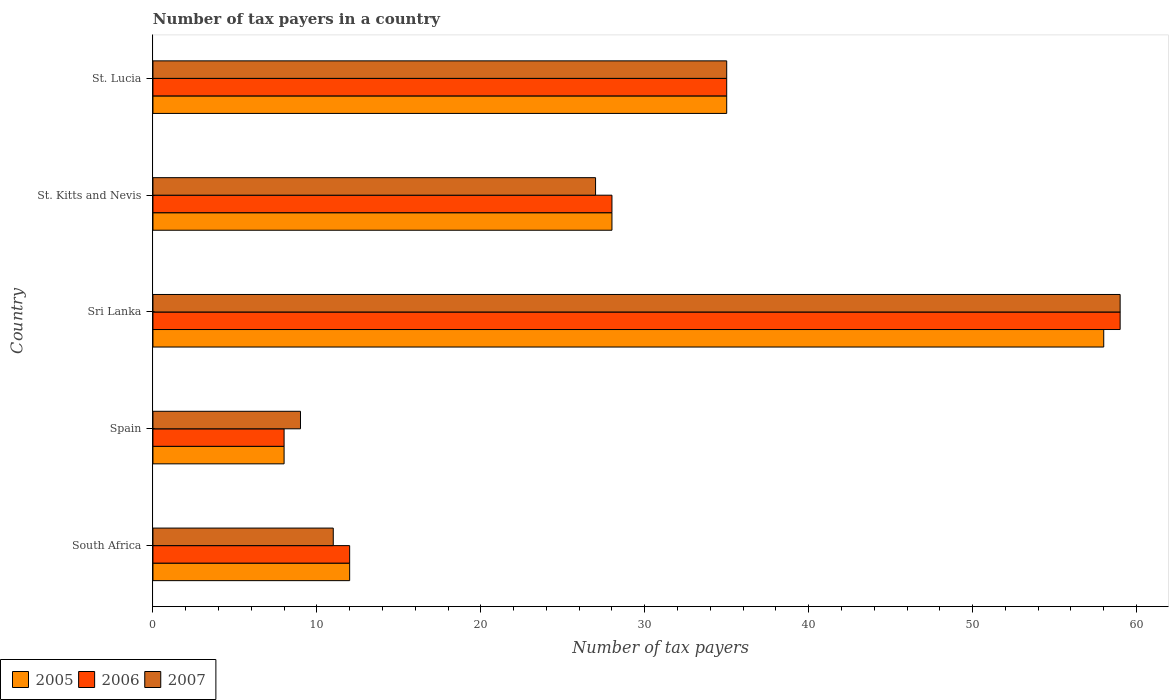How many different coloured bars are there?
Offer a terse response. 3. How many groups of bars are there?
Your answer should be very brief. 5. Are the number of bars on each tick of the Y-axis equal?
Your answer should be compact. Yes. How many bars are there on the 3rd tick from the bottom?
Provide a succinct answer. 3. What is the label of the 3rd group of bars from the top?
Offer a terse response. Sri Lanka. What is the number of tax payers in in 2007 in Sri Lanka?
Keep it short and to the point. 59. Across all countries, what is the maximum number of tax payers in in 2005?
Offer a terse response. 58. In which country was the number of tax payers in in 2005 maximum?
Make the answer very short. Sri Lanka. In which country was the number of tax payers in in 2005 minimum?
Ensure brevity in your answer.  Spain. What is the total number of tax payers in in 2006 in the graph?
Offer a terse response. 142. What is the difference between the number of tax payers in in 2007 in South Africa and that in Sri Lanka?
Provide a short and direct response. -48. What is the difference between the number of tax payers in in 2007 in Spain and the number of tax payers in in 2006 in South Africa?
Offer a very short reply. -3. What is the average number of tax payers in in 2005 per country?
Ensure brevity in your answer.  28.2. What is the ratio of the number of tax payers in in 2007 in Sri Lanka to that in St. Kitts and Nevis?
Offer a very short reply. 2.19. What is the difference between the highest and the lowest number of tax payers in in 2007?
Make the answer very short. 50. Is it the case that in every country, the sum of the number of tax payers in in 2007 and number of tax payers in in 2005 is greater than the number of tax payers in in 2006?
Keep it short and to the point. Yes. What is the difference between two consecutive major ticks on the X-axis?
Make the answer very short. 10. Are the values on the major ticks of X-axis written in scientific E-notation?
Your answer should be very brief. No. Does the graph contain any zero values?
Give a very brief answer. No. Where does the legend appear in the graph?
Your answer should be very brief. Bottom left. How are the legend labels stacked?
Offer a terse response. Horizontal. What is the title of the graph?
Your answer should be very brief. Number of tax payers in a country. What is the label or title of the X-axis?
Your answer should be compact. Number of tax payers. What is the Number of tax payers in 2005 in South Africa?
Keep it short and to the point. 12. What is the Number of tax payers of 2006 in South Africa?
Make the answer very short. 12. What is the Number of tax payers in 2007 in South Africa?
Offer a very short reply. 11. What is the Number of tax payers of 2005 in Sri Lanka?
Your answer should be very brief. 58. What is the Number of tax payers in 2006 in Sri Lanka?
Provide a short and direct response. 59. What is the Number of tax payers of 2005 in St. Kitts and Nevis?
Your answer should be very brief. 28. What is the Number of tax payers of 2005 in St. Lucia?
Give a very brief answer. 35. What is the Number of tax payers in 2006 in St. Lucia?
Provide a short and direct response. 35. Across all countries, what is the maximum Number of tax payers in 2006?
Give a very brief answer. 59. Across all countries, what is the maximum Number of tax payers of 2007?
Keep it short and to the point. 59. Across all countries, what is the minimum Number of tax payers in 2006?
Ensure brevity in your answer.  8. Across all countries, what is the minimum Number of tax payers of 2007?
Make the answer very short. 9. What is the total Number of tax payers of 2005 in the graph?
Your answer should be very brief. 141. What is the total Number of tax payers in 2006 in the graph?
Offer a very short reply. 142. What is the total Number of tax payers of 2007 in the graph?
Ensure brevity in your answer.  141. What is the difference between the Number of tax payers of 2006 in South Africa and that in Spain?
Keep it short and to the point. 4. What is the difference between the Number of tax payers of 2007 in South Africa and that in Spain?
Ensure brevity in your answer.  2. What is the difference between the Number of tax payers in 2005 in South Africa and that in Sri Lanka?
Make the answer very short. -46. What is the difference between the Number of tax payers of 2006 in South Africa and that in Sri Lanka?
Offer a terse response. -47. What is the difference between the Number of tax payers of 2007 in South Africa and that in Sri Lanka?
Provide a succinct answer. -48. What is the difference between the Number of tax payers of 2005 in South Africa and that in St. Kitts and Nevis?
Give a very brief answer. -16. What is the difference between the Number of tax payers of 2007 in South Africa and that in St. Lucia?
Give a very brief answer. -24. What is the difference between the Number of tax payers of 2006 in Spain and that in Sri Lanka?
Provide a succinct answer. -51. What is the difference between the Number of tax payers of 2007 in Spain and that in Sri Lanka?
Offer a very short reply. -50. What is the difference between the Number of tax payers in 2005 in Spain and that in St. Lucia?
Ensure brevity in your answer.  -27. What is the difference between the Number of tax payers of 2005 in Sri Lanka and that in St. Kitts and Nevis?
Give a very brief answer. 30. What is the difference between the Number of tax payers of 2005 in Sri Lanka and that in St. Lucia?
Give a very brief answer. 23. What is the difference between the Number of tax payers of 2006 in Sri Lanka and that in St. Lucia?
Offer a very short reply. 24. What is the difference between the Number of tax payers of 2006 in St. Kitts and Nevis and that in St. Lucia?
Make the answer very short. -7. What is the difference between the Number of tax payers in 2007 in St. Kitts and Nevis and that in St. Lucia?
Give a very brief answer. -8. What is the difference between the Number of tax payers of 2005 in South Africa and the Number of tax payers of 2006 in Spain?
Ensure brevity in your answer.  4. What is the difference between the Number of tax payers of 2005 in South Africa and the Number of tax payers of 2007 in Spain?
Offer a very short reply. 3. What is the difference between the Number of tax payers of 2005 in South Africa and the Number of tax payers of 2006 in Sri Lanka?
Make the answer very short. -47. What is the difference between the Number of tax payers in 2005 in South Africa and the Number of tax payers in 2007 in Sri Lanka?
Offer a terse response. -47. What is the difference between the Number of tax payers of 2006 in South Africa and the Number of tax payers of 2007 in Sri Lanka?
Provide a short and direct response. -47. What is the difference between the Number of tax payers of 2006 in South Africa and the Number of tax payers of 2007 in St. Kitts and Nevis?
Provide a short and direct response. -15. What is the difference between the Number of tax payers in 2005 in South Africa and the Number of tax payers in 2007 in St. Lucia?
Provide a succinct answer. -23. What is the difference between the Number of tax payers in 2005 in Spain and the Number of tax payers in 2006 in Sri Lanka?
Provide a succinct answer. -51. What is the difference between the Number of tax payers in 2005 in Spain and the Number of tax payers in 2007 in Sri Lanka?
Your answer should be compact. -51. What is the difference between the Number of tax payers of 2006 in Spain and the Number of tax payers of 2007 in Sri Lanka?
Offer a terse response. -51. What is the difference between the Number of tax payers in 2005 in Spain and the Number of tax payers in 2006 in St. Kitts and Nevis?
Offer a terse response. -20. What is the difference between the Number of tax payers in 2006 in Spain and the Number of tax payers in 2007 in St. Kitts and Nevis?
Keep it short and to the point. -19. What is the difference between the Number of tax payers in 2005 in Spain and the Number of tax payers in 2006 in St. Lucia?
Provide a succinct answer. -27. What is the difference between the Number of tax payers in 2005 in Spain and the Number of tax payers in 2007 in St. Lucia?
Make the answer very short. -27. What is the difference between the Number of tax payers of 2005 in Sri Lanka and the Number of tax payers of 2007 in St. Kitts and Nevis?
Offer a very short reply. 31. What is the difference between the Number of tax payers in 2005 in St. Kitts and Nevis and the Number of tax payers in 2006 in St. Lucia?
Your response must be concise. -7. What is the difference between the Number of tax payers in 2005 in St. Kitts and Nevis and the Number of tax payers in 2007 in St. Lucia?
Provide a short and direct response. -7. What is the average Number of tax payers of 2005 per country?
Provide a succinct answer. 28.2. What is the average Number of tax payers of 2006 per country?
Your answer should be very brief. 28.4. What is the average Number of tax payers of 2007 per country?
Keep it short and to the point. 28.2. What is the difference between the Number of tax payers of 2005 and Number of tax payers of 2006 in South Africa?
Your answer should be compact. 0. What is the difference between the Number of tax payers in 2006 and Number of tax payers in 2007 in Spain?
Your answer should be very brief. -1. What is the difference between the Number of tax payers of 2005 and Number of tax payers of 2006 in Sri Lanka?
Your answer should be very brief. -1. What is the difference between the Number of tax payers in 2006 and Number of tax payers in 2007 in Sri Lanka?
Keep it short and to the point. 0. What is the difference between the Number of tax payers of 2005 and Number of tax payers of 2006 in St. Kitts and Nevis?
Your answer should be very brief. 0. What is the difference between the Number of tax payers of 2005 and Number of tax payers of 2007 in St. Kitts and Nevis?
Provide a short and direct response. 1. What is the ratio of the Number of tax payers in 2006 in South Africa to that in Spain?
Offer a very short reply. 1.5. What is the ratio of the Number of tax payers in 2007 in South Africa to that in Spain?
Offer a terse response. 1.22. What is the ratio of the Number of tax payers in 2005 in South Africa to that in Sri Lanka?
Make the answer very short. 0.21. What is the ratio of the Number of tax payers in 2006 in South Africa to that in Sri Lanka?
Offer a very short reply. 0.2. What is the ratio of the Number of tax payers in 2007 in South Africa to that in Sri Lanka?
Make the answer very short. 0.19. What is the ratio of the Number of tax payers of 2005 in South Africa to that in St. Kitts and Nevis?
Your response must be concise. 0.43. What is the ratio of the Number of tax payers of 2006 in South Africa to that in St. Kitts and Nevis?
Your response must be concise. 0.43. What is the ratio of the Number of tax payers of 2007 in South Africa to that in St. Kitts and Nevis?
Your answer should be very brief. 0.41. What is the ratio of the Number of tax payers in 2005 in South Africa to that in St. Lucia?
Ensure brevity in your answer.  0.34. What is the ratio of the Number of tax payers in 2006 in South Africa to that in St. Lucia?
Offer a very short reply. 0.34. What is the ratio of the Number of tax payers in 2007 in South Africa to that in St. Lucia?
Give a very brief answer. 0.31. What is the ratio of the Number of tax payers in 2005 in Spain to that in Sri Lanka?
Provide a short and direct response. 0.14. What is the ratio of the Number of tax payers of 2006 in Spain to that in Sri Lanka?
Offer a very short reply. 0.14. What is the ratio of the Number of tax payers in 2007 in Spain to that in Sri Lanka?
Provide a short and direct response. 0.15. What is the ratio of the Number of tax payers in 2005 in Spain to that in St. Kitts and Nevis?
Your answer should be very brief. 0.29. What is the ratio of the Number of tax payers of 2006 in Spain to that in St. Kitts and Nevis?
Your response must be concise. 0.29. What is the ratio of the Number of tax payers in 2005 in Spain to that in St. Lucia?
Your answer should be very brief. 0.23. What is the ratio of the Number of tax payers in 2006 in Spain to that in St. Lucia?
Offer a very short reply. 0.23. What is the ratio of the Number of tax payers in 2007 in Spain to that in St. Lucia?
Keep it short and to the point. 0.26. What is the ratio of the Number of tax payers of 2005 in Sri Lanka to that in St. Kitts and Nevis?
Keep it short and to the point. 2.07. What is the ratio of the Number of tax payers of 2006 in Sri Lanka to that in St. Kitts and Nevis?
Make the answer very short. 2.11. What is the ratio of the Number of tax payers of 2007 in Sri Lanka to that in St. Kitts and Nevis?
Offer a terse response. 2.19. What is the ratio of the Number of tax payers in 2005 in Sri Lanka to that in St. Lucia?
Offer a terse response. 1.66. What is the ratio of the Number of tax payers in 2006 in Sri Lanka to that in St. Lucia?
Ensure brevity in your answer.  1.69. What is the ratio of the Number of tax payers of 2007 in Sri Lanka to that in St. Lucia?
Offer a very short reply. 1.69. What is the ratio of the Number of tax payers in 2006 in St. Kitts and Nevis to that in St. Lucia?
Your answer should be compact. 0.8. What is the ratio of the Number of tax payers of 2007 in St. Kitts and Nevis to that in St. Lucia?
Provide a succinct answer. 0.77. What is the difference between the highest and the second highest Number of tax payers of 2005?
Keep it short and to the point. 23. What is the difference between the highest and the second highest Number of tax payers in 2006?
Keep it short and to the point. 24. What is the difference between the highest and the second highest Number of tax payers of 2007?
Your answer should be compact. 24. 